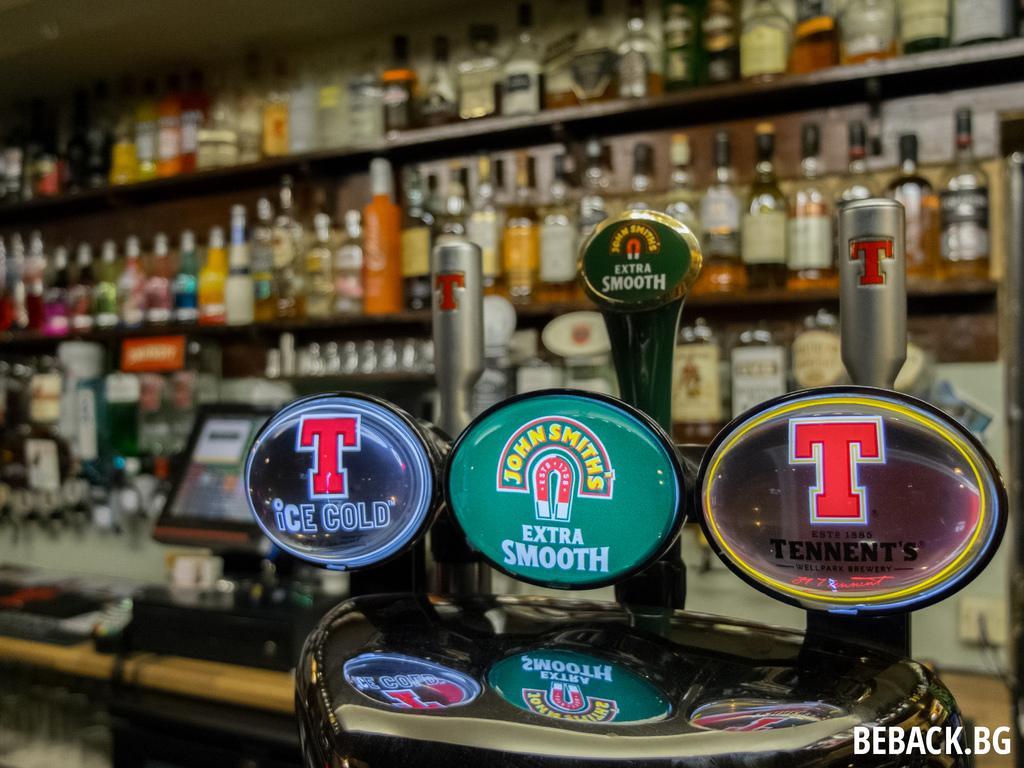How would you summarize this image in a sentence or two? In this image we can see a monitor, table, and few objects. At the bottom of the image we can see something is written on it. In the background we can see bottles on the racks. 